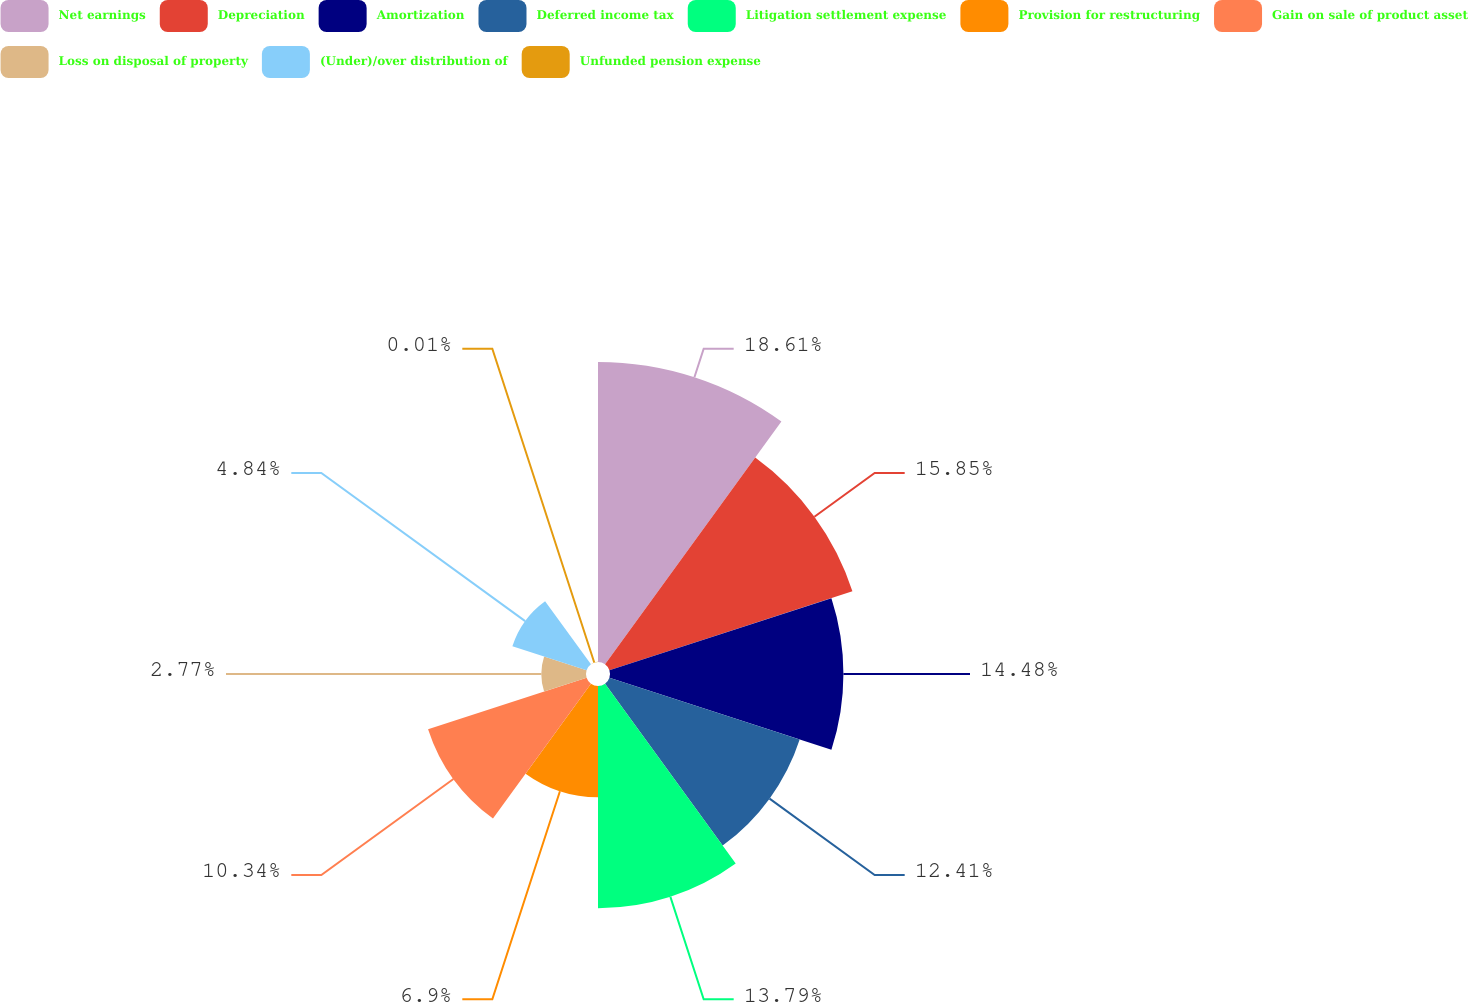Convert chart. <chart><loc_0><loc_0><loc_500><loc_500><pie_chart><fcel>Net earnings<fcel>Depreciation<fcel>Amortization<fcel>Deferred income tax<fcel>Litigation settlement expense<fcel>Provision for restructuring<fcel>Gain on sale of product asset<fcel>Loss on disposal of property<fcel>(Under)/over distribution of<fcel>Unfunded pension expense<nl><fcel>18.61%<fcel>15.85%<fcel>14.48%<fcel>12.41%<fcel>13.79%<fcel>6.9%<fcel>10.34%<fcel>2.77%<fcel>4.84%<fcel>0.01%<nl></chart> 